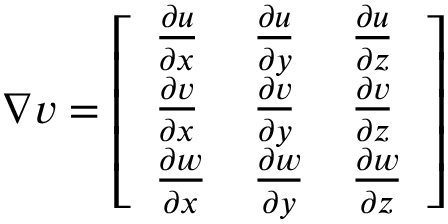Convert formula to latex. <formula><loc_0><loc_0><loc_500><loc_500>\begin{array} { r } { \nabla v = \left [ \begin{array} { l l l } { \frac { \partial u } { \partial x } } & { \frac { \partial u } { \partial y } } & { \frac { \partial u } { \partial z } } \\ { \frac { \partial v } { \partial x } } & { \frac { \partial v } { \partial y } } & { \frac { \partial v } { \partial z } } \\ { \frac { \partial w } { \partial x } } & { \frac { \partial w } { \partial y } } & { \frac { \partial w } { \partial z } } \end{array} \right ] } \end{array}</formula> 